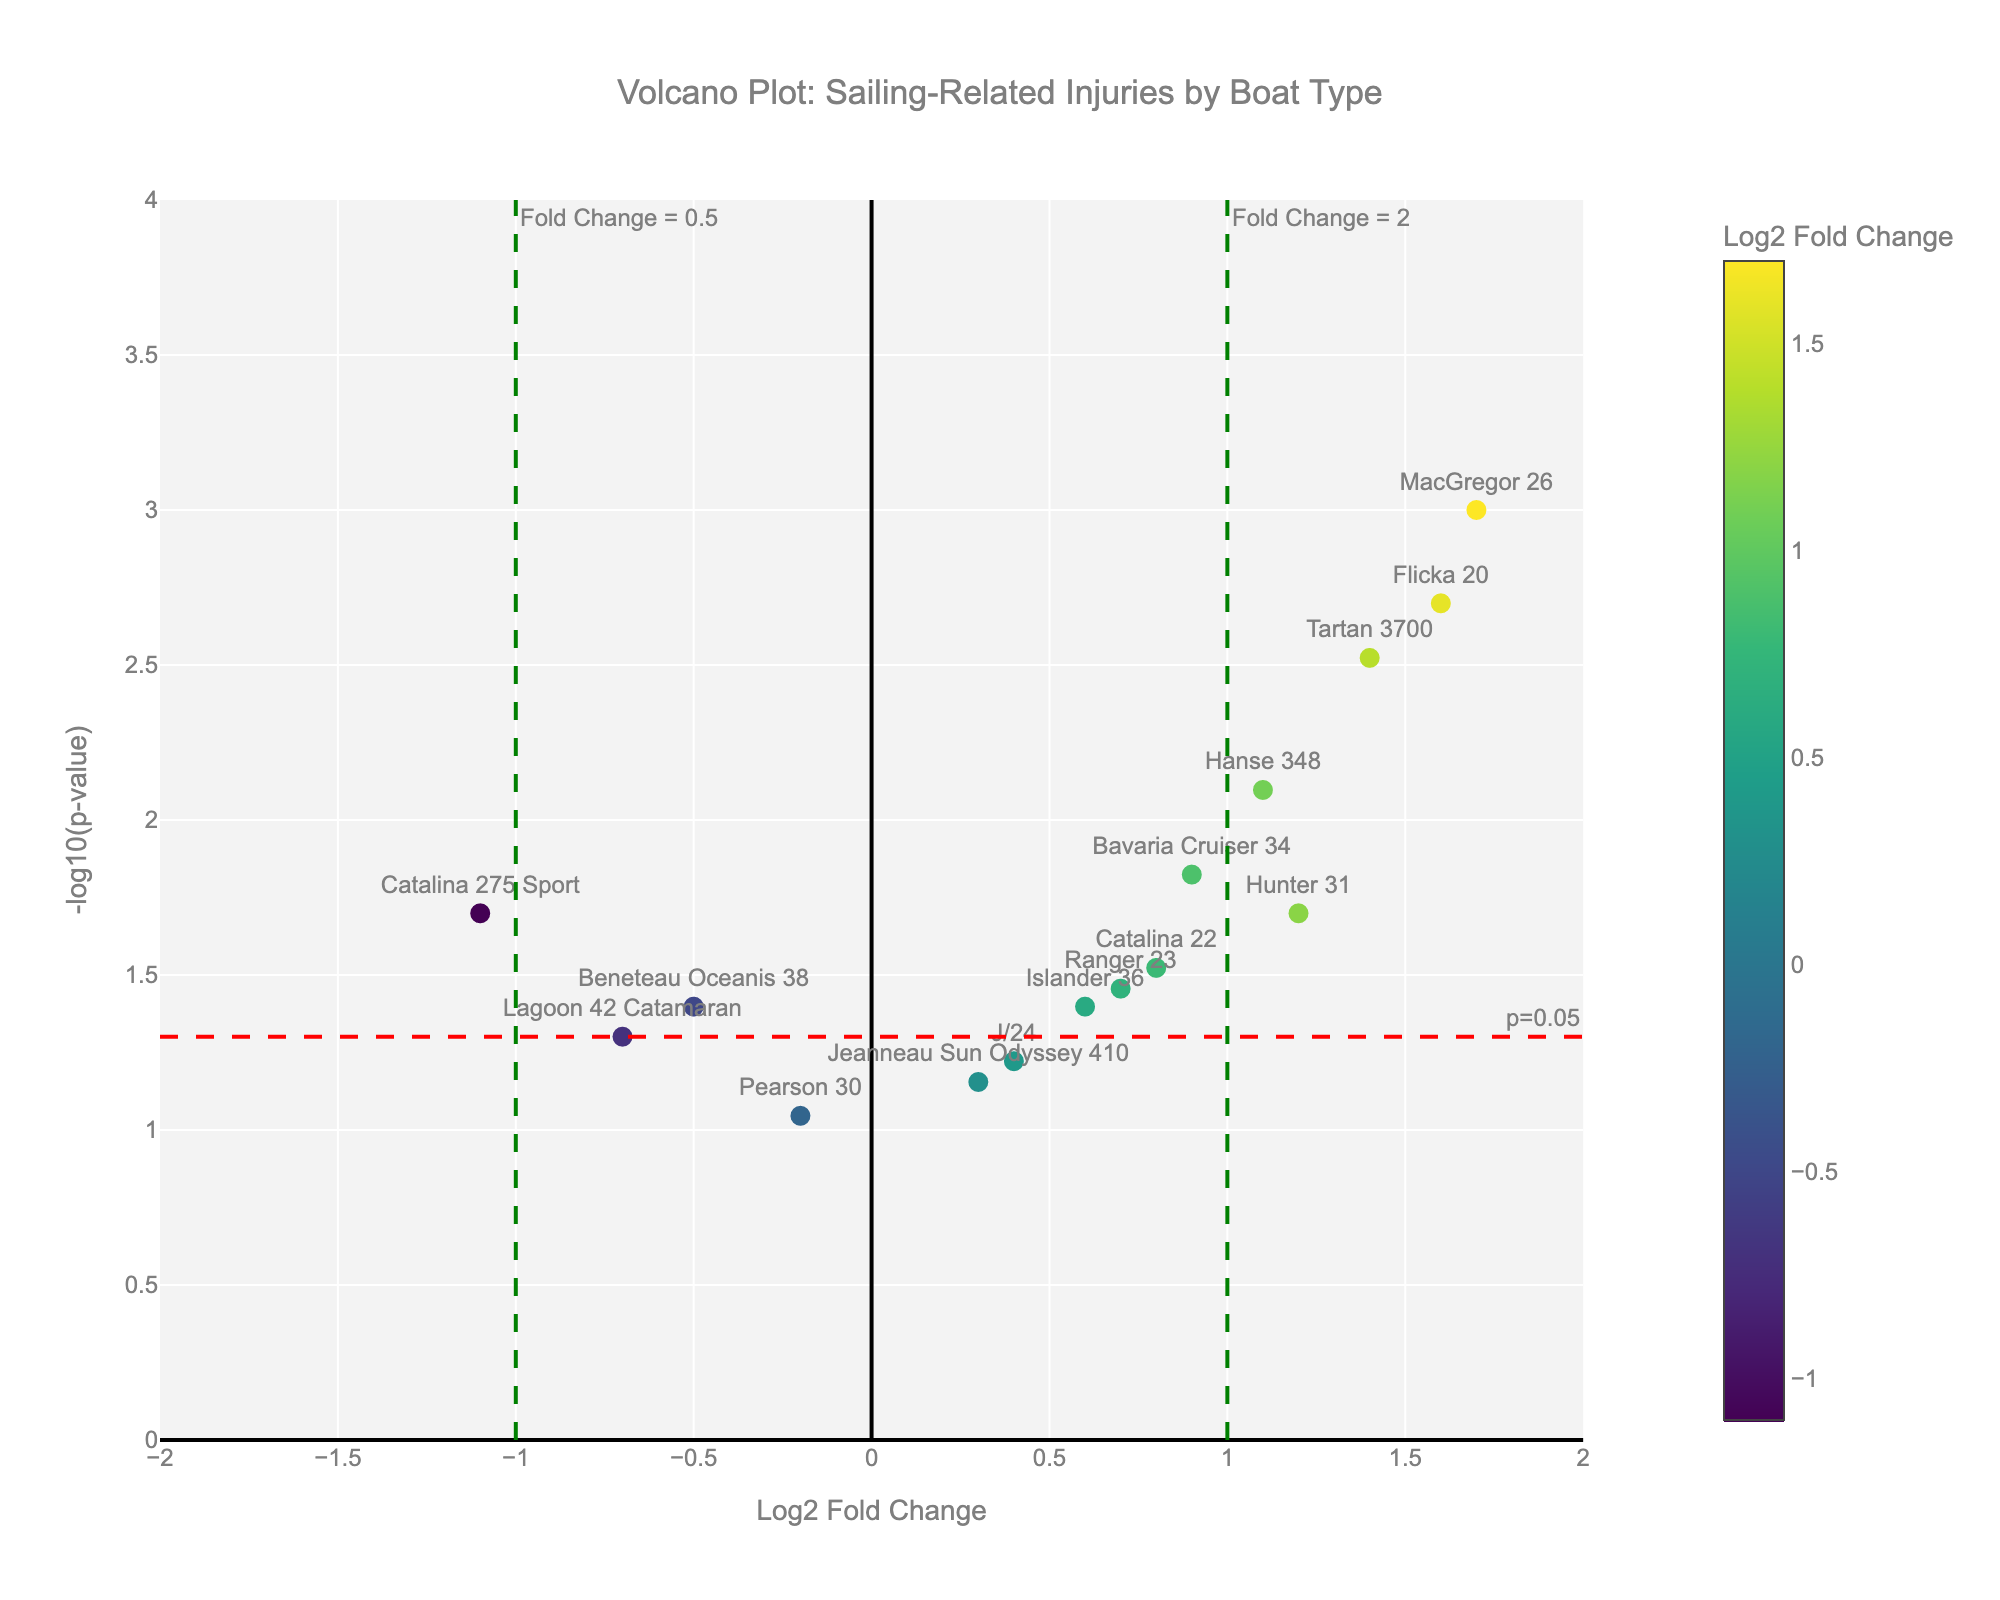How many data points are shown in the plot? Visually count the number of markers representing data points in the plot. There are 14 markers corresponding to 14 boat types and injury types listed.
Answer: 14 What is the highest -log10(p-value) and which injury type does it correspond to? Identify the data point with the highest y-value (−log10(p-value)). This point corresponds to the MacGregor 26 with the injury of Falling Overboard (-log10(p-value) ≈ 3).
Answer: Falling Overboard Which boat type has the most significant fold change in injuries? The boat type with the highest absolute x-value (Log2 Fold Change) indicates the most significant fold change. Catalina 275 Sport has the lowest Log2 Fold Change of -1.1 (most significant spread).
Answer: Catalina 275 Sport What color gradient indicates higher Log2 Fold Change values in the plot? The color scale on the plot ranges from one color to another using Viridis as a colormap. Higher fold change values are indicated by darker colors (such as dark green and blue).
Answer: Dark green/blue Which types of injuries are more frequent in boats with a Log2 Fold Change greater than 1? Examine all data points with an x-value greater than 1 and identify corresponding injuries. The injuries are Rope Burn (Hunter 31), Falling Overboard (MacGregor 26), Head Injury (Bavaria Cruiser 34), Finger Pinching (Hanse 348), Cuts and Scrapes (Tartan 3700), and Concussion (Flicka 20).
Answer: Rope Burn, Falling Overboard, Head Injury, Finger Pinching, Cuts and Scrapes, Concussion How many injuries had a Log2 Fold Change between -1 and 1? Count all data points with x-values within the range of -1 and 1. You will find the following: Sunburn (Catalina 22), Bruising (Beneteau Oceanis 38), Seasickness (Jeanneau Sun Odyssey 410), Sprained Ankle (Pearson 30), Dehydration (Lagoon 42 Catamaran), Hypothermia (Islander 36), Jellyfish Sting (Catalina 275 Sport), Muscle Strain (J/24), Wind Burn (Ranger 23).
Answer: 9 Which injury type has the least significant p-value but still below 0.05? Identify the point that has the highest p-value that is still below 0.05. Wind Burn has the highest p-value of 0.035 that is still below 0.05. (-log10(0.035) = log10 ≈ 1.46).
Answer: Wind Burn Is there any injury type associated with a boat that showed a fold change (below 0.5) log2 value which is significantly different? Look for data points left of x = -1 and identify the resulting injury types. Dehydration (Lagoon 42 Catamaran) has a Log2 Fold Change of -0.7 and Jellyfish Sting (Catalina 275 Sport) has -1.1. Both qualify at these log2 values being significant enough, p-value less than 0.05.
Answer: Dehydration, Jellyfish Sting What is the most common type of family-friendly boats indicated in this plot that have non-extreme injury types (Log2 Fold Change between -1 and 1)? Count and list the boats within -1 and 1 Log2 Fold Change band, which many family friendly boats possess like Catalina 22, Jeanneau Sun Odyssey 410.
Answer: Catalina 22, Jeanneau Sun Odyssey 410 